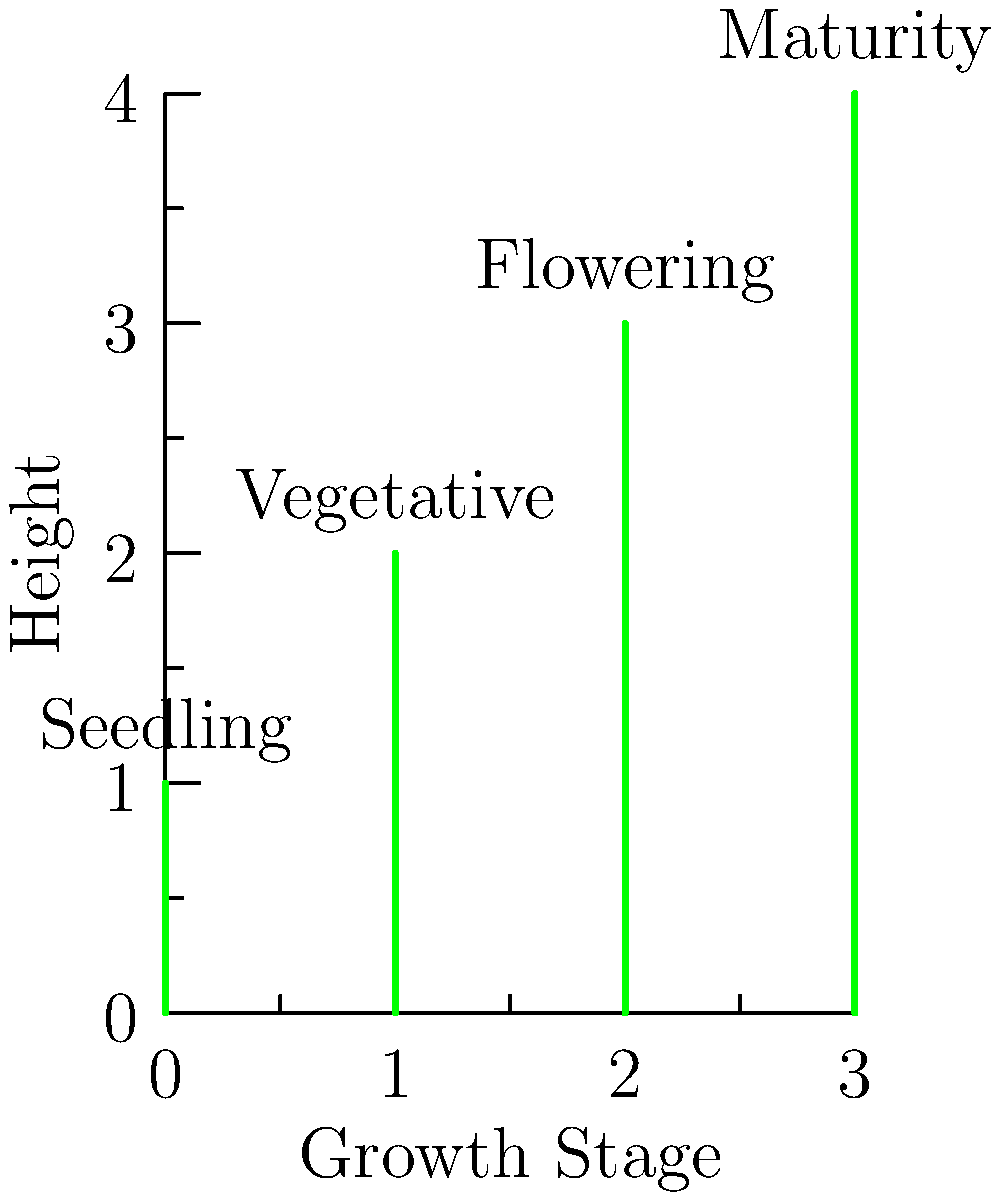As a farmer, you're monitoring the growth stages of your crops. Based on the diagram showing different plant heights representing various growth stages, which stage typically requires the most attention in terms of pest control and nutrient management? To answer this question, let's analyze each growth stage:

1. Seedling stage: Plants are small and vulnerable, but pest pressure is usually lower.
2. Vegetative stage: Plants are growing rapidly, requiring nutrients but still relatively resilient.
3. Flowering stage: This is a critical period for most crops, as it determines yield potential.
4. Maturity stage: Plants are fully grown and starting to produce harvestable parts.

The flowering stage (third plant in the diagram) is typically the most crucial for pest control and nutrient management because:

1. It's when the plant is setting the foundation for its yield (fruits, grains, etc.).
2. Many pests are attracted to flowering plants, potentially causing significant damage.
3. Nutrient demands are high as the plant diverts resources to reproductive structures.
4. Stress during this stage can have the most severe impact on final crop yield.

Therefore, farmers often need to pay extra attention to pest control and ensure adequate nutrient availability during the flowering stage to maximize crop productivity.
Answer: Flowering stage 